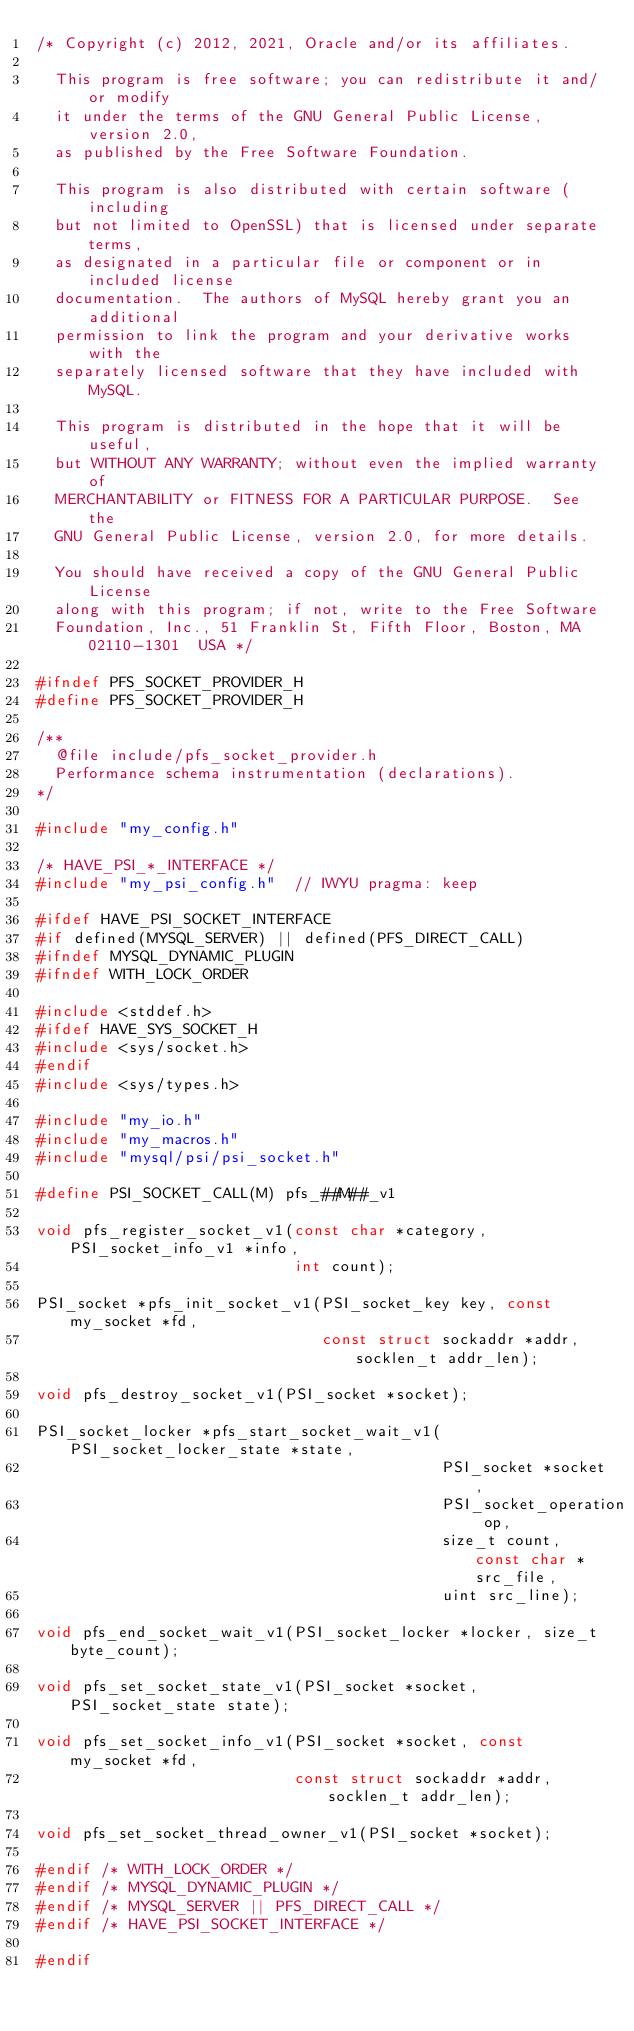<code> <loc_0><loc_0><loc_500><loc_500><_C_>/* Copyright (c) 2012, 2021, Oracle and/or its affiliates.

  This program is free software; you can redistribute it and/or modify
  it under the terms of the GNU General Public License, version 2.0,
  as published by the Free Software Foundation.

  This program is also distributed with certain software (including
  but not limited to OpenSSL) that is licensed under separate terms,
  as designated in a particular file or component or in included license
  documentation.  The authors of MySQL hereby grant you an additional
  permission to link the program and your derivative works with the
  separately licensed software that they have included with MySQL.

  This program is distributed in the hope that it will be useful,
  but WITHOUT ANY WARRANTY; without even the implied warranty of
  MERCHANTABILITY or FITNESS FOR A PARTICULAR PURPOSE.  See the
  GNU General Public License, version 2.0, for more details.

  You should have received a copy of the GNU General Public License
  along with this program; if not, write to the Free Software
  Foundation, Inc., 51 Franklin St, Fifth Floor, Boston, MA 02110-1301  USA */

#ifndef PFS_SOCKET_PROVIDER_H
#define PFS_SOCKET_PROVIDER_H

/**
  @file include/pfs_socket_provider.h
  Performance schema instrumentation (declarations).
*/

#include "my_config.h"

/* HAVE_PSI_*_INTERFACE */
#include "my_psi_config.h"  // IWYU pragma: keep

#ifdef HAVE_PSI_SOCKET_INTERFACE
#if defined(MYSQL_SERVER) || defined(PFS_DIRECT_CALL)
#ifndef MYSQL_DYNAMIC_PLUGIN
#ifndef WITH_LOCK_ORDER

#include <stddef.h>
#ifdef HAVE_SYS_SOCKET_H
#include <sys/socket.h>
#endif
#include <sys/types.h>

#include "my_io.h"
#include "my_macros.h"
#include "mysql/psi/psi_socket.h"

#define PSI_SOCKET_CALL(M) pfs_##M##_v1

void pfs_register_socket_v1(const char *category, PSI_socket_info_v1 *info,
                            int count);

PSI_socket *pfs_init_socket_v1(PSI_socket_key key, const my_socket *fd,
                               const struct sockaddr *addr, socklen_t addr_len);

void pfs_destroy_socket_v1(PSI_socket *socket);

PSI_socket_locker *pfs_start_socket_wait_v1(PSI_socket_locker_state *state,
                                            PSI_socket *socket,
                                            PSI_socket_operation op,
                                            size_t count, const char *src_file,
                                            uint src_line);

void pfs_end_socket_wait_v1(PSI_socket_locker *locker, size_t byte_count);

void pfs_set_socket_state_v1(PSI_socket *socket, PSI_socket_state state);

void pfs_set_socket_info_v1(PSI_socket *socket, const my_socket *fd,
                            const struct sockaddr *addr, socklen_t addr_len);

void pfs_set_socket_thread_owner_v1(PSI_socket *socket);

#endif /* WITH_LOCK_ORDER */
#endif /* MYSQL_DYNAMIC_PLUGIN */
#endif /* MYSQL_SERVER || PFS_DIRECT_CALL */
#endif /* HAVE_PSI_SOCKET_INTERFACE */

#endif
</code> 